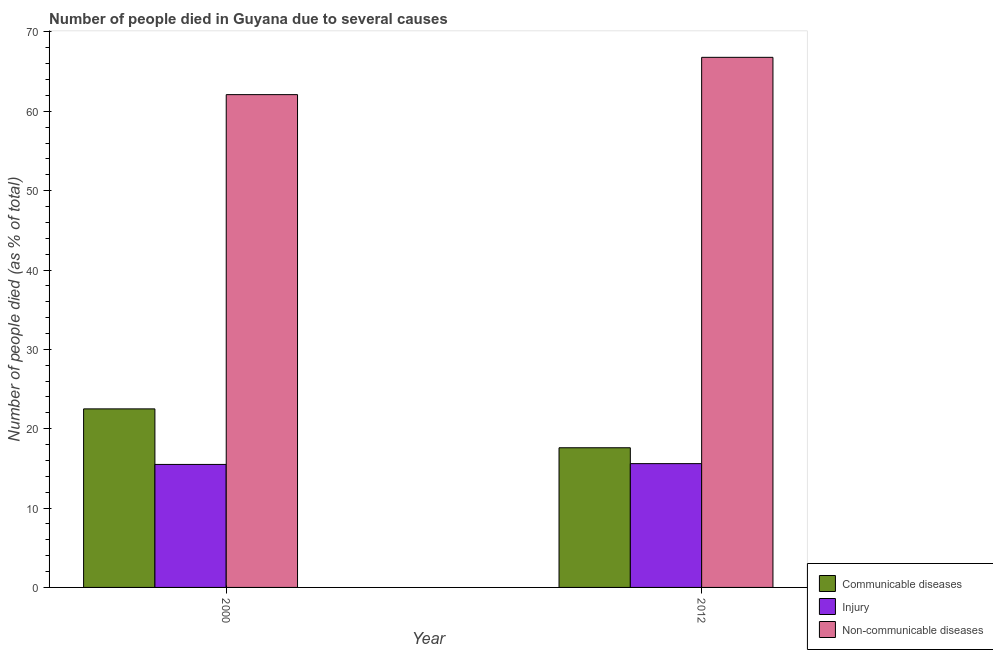How many different coloured bars are there?
Offer a very short reply. 3. Are the number of bars per tick equal to the number of legend labels?
Provide a succinct answer. Yes. How many bars are there on the 1st tick from the left?
Ensure brevity in your answer.  3. How many bars are there on the 1st tick from the right?
Your answer should be very brief. 3. What is the label of the 1st group of bars from the left?
Your answer should be compact. 2000. What is the number of people who died of injury in 2000?
Keep it short and to the point. 15.5. Across all years, what is the maximum number of people who dies of non-communicable diseases?
Your response must be concise. 66.8. Across all years, what is the minimum number of people who dies of non-communicable diseases?
Make the answer very short. 62.1. In which year was the number of people who died of communicable diseases maximum?
Ensure brevity in your answer.  2000. In which year was the number of people who died of communicable diseases minimum?
Provide a succinct answer. 2012. What is the total number of people who died of injury in the graph?
Ensure brevity in your answer.  31.1. What is the difference between the number of people who died of injury in 2000 and that in 2012?
Your answer should be very brief. -0.1. What is the difference between the number of people who died of injury in 2000 and the number of people who dies of non-communicable diseases in 2012?
Your answer should be compact. -0.1. What is the average number of people who died of injury per year?
Your answer should be very brief. 15.55. What is the ratio of the number of people who dies of non-communicable diseases in 2000 to that in 2012?
Your response must be concise. 0.93. Is the number of people who died of communicable diseases in 2000 less than that in 2012?
Ensure brevity in your answer.  No. What does the 2nd bar from the left in 2000 represents?
Offer a terse response. Injury. What does the 1st bar from the right in 2012 represents?
Keep it short and to the point. Non-communicable diseases. Are all the bars in the graph horizontal?
Make the answer very short. No. How many years are there in the graph?
Offer a very short reply. 2. What is the difference between two consecutive major ticks on the Y-axis?
Provide a succinct answer. 10. Does the graph contain any zero values?
Make the answer very short. No. Does the graph contain grids?
Your answer should be compact. No. How many legend labels are there?
Keep it short and to the point. 3. How are the legend labels stacked?
Provide a short and direct response. Vertical. What is the title of the graph?
Your response must be concise. Number of people died in Guyana due to several causes. Does "Ages 15-20" appear as one of the legend labels in the graph?
Your answer should be very brief. No. What is the label or title of the Y-axis?
Provide a succinct answer. Number of people died (as % of total). What is the Number of people died (as % of total) in Injury in 2000?
Your answer should be very brief. 15.5. What is the Number of people died (as % of total) of Non-communicable diseases in 2000?
Provide a short and direct response. 62.1. What is the Number of people died (as % of total) in Non-communicable diseases in 2012?
Your answer should be very brief. 66.8. Across all years, what is the maximum Number of people died (as % of total) of Communicable diseases?
Ensure brevity in your answer.  22.5. Across all years, what is the maximum Number of people died (as % of total) in Non-communicable diseases?
Give a very brief answer. 66.8. Across all years, what is the minimum Number of people died (as % of total) of Communicable diseases?
Offer a terse response. 17.6. Across all years, what is the minimum Number of people died (as % of total) of Non-communicable diseases?
Provide a succinct answer. 62.1. What is the total Number of people died (as % of total) in Communicable diseases in the graph?
Keep it short and to the point. 40.1. What is the total Number of people died (as % of total) in Injury in the graph?
Your answer should be compact. 31.1. What is the total Number of people died (as % of total) in Non-communicable diseases in the graph?
Your answer should be compact. 128.9. What is the difference between the Number of people died (as % of total) in Communicable diseases in 2000 and that in 2012?
Provide a succinct answer. 4.9. What is the difference between the Number of people died (as % of total) of Injury in 2000 and that in 2012?
Your response must be concise. -0.1. What is the difference between the Number of people died (as % of total) in Non-communicable diseases in 2000 and that in 2012?
Your answer should be very brief. -4.7. What is the difference between the Number of people died (as % of total) of Communicable diseases in 2000 and the Number of people died (as % of total) of Injury in 2012?
Your response must be concise. 6.9. What is the difference between the Number of people died (as % of total) in Communicable diseases in 2000 and the Number of people died (as % of total) in Non-communicable diseases in 2012?
Offer a terse response. -44.3. What is the difference between the Number of people died (as % of total) of Injury in 2000 and the Number of people died (as % of total) of Non-communicable diseases in 2012?
Ensure brevity in your answer.  -51.3. What is the average Number of people died (as % of total) of Communicable diseases per year?
Keep it short and to the point. 20.05. What is the average Number of people died (as % of total) in Injury per year?
Your response must be concise. 15.55. What is the average Number of people died (as % of total) in Non-communicable diseases per year?
Offer a terse response. 64.45. In the year 2000, what is the difference between the Number of people died (as % of total) in Communicable diseases and Number of people died (as % of total) in Injury?
Keep it short and to the point. 7. In the year 2000, what is the difference between the Number of people died (as % of total) of Communicable diseases and Number of people died (as % of total) of Non-communicable diseases?
Your response must be concise. -39.6. In the year 2000, what is the difference between the Number of people died (as % of total) of Injury and Number of people died (as % of total) of Non-communicable diseases?
Keep it short and to the point. -46.6. In the year 2012, what is the difference between the Number of people died (as % of total) of Communicable diseases and Number of people died (as % of total) of Injury?
Make the answer very short. 2. In the year 2012, what is the difference between the Number of people died (as % of total) of Communicable diseases and Number of people died (as % of total) of Non-communicable diseases?
Provide a succinct answer. -49.2. In the year 2012, what is the difference between the Number of people died (as % of total) of Injury and Number of people died (as % of total) of Non-communicable diseases?
Offer a terse response. -51.2. What is the ratio of the Number of people died (as % of total) in Communicable diseases in 2000 to that in 2012?
Provide a succinct answer. 1.28. What is the ratio of the Number of people died (as % of total) of Injury in 2000 to that in 2012?
Ensure brevity in your answer.  0.99. What is the ratio of the Number of people died (as % of total) of Non-communicable diseases in 2000 to that in 2012?
Offer a very short reply. 0.93. What is the difference between the highest and the lowest Number of people died (as % of total) in Injury?
Your answer should be compact. 0.1. 